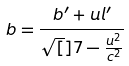Convert formula to latex. <formula><loc_0><loc_0><loc_500><loc_500>b = \frac { b ^ { \prime } + u l ^ { \prime } } { \sqrt { [ } ] { 7 - \frac { u ^ { 2 } } { c ^ { 2 } } } }</formula> 